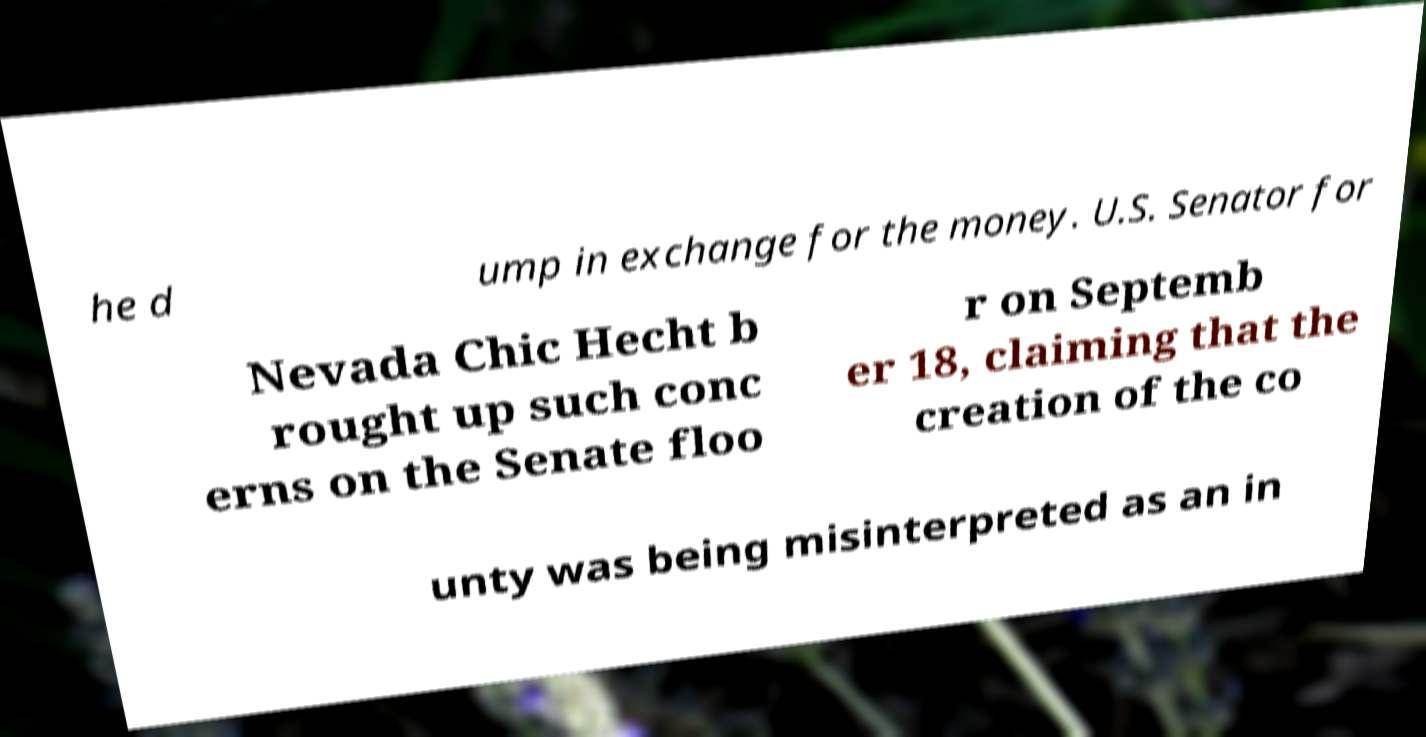Please identify and transcribe the text found in this image. he d ump in exchange for the money. U.S. Senator for Nevada Chic Hecht b rought up such conc erns on the Senate floo r on Septemb er 18, claiming that the creation of the co unty was being misinterpreted as an in 